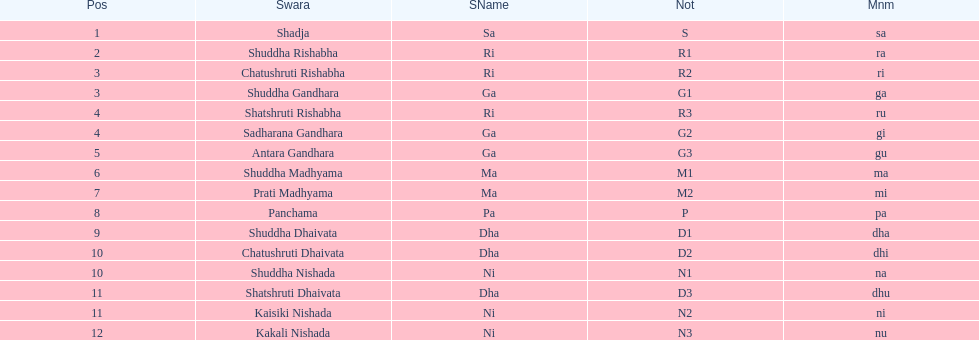On average how many of the swara have a short name that begin with d or g? 6. 